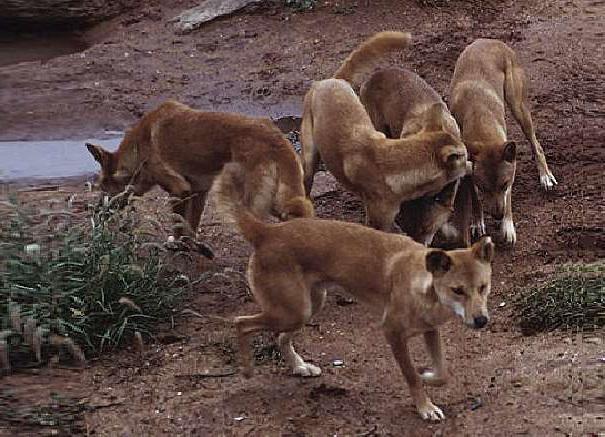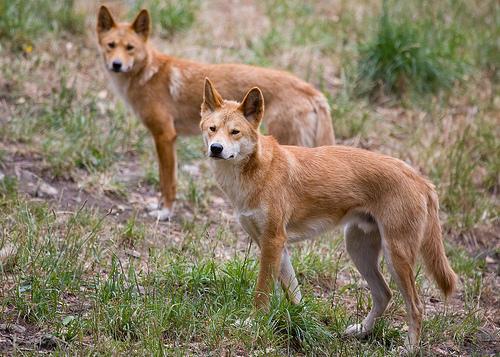The first image is the image on the left, the second image is the image on the right. Given the left and right images, does the statement "There are no more than two dingo's in the right image." hold true? Answer yes or no. Yes. 